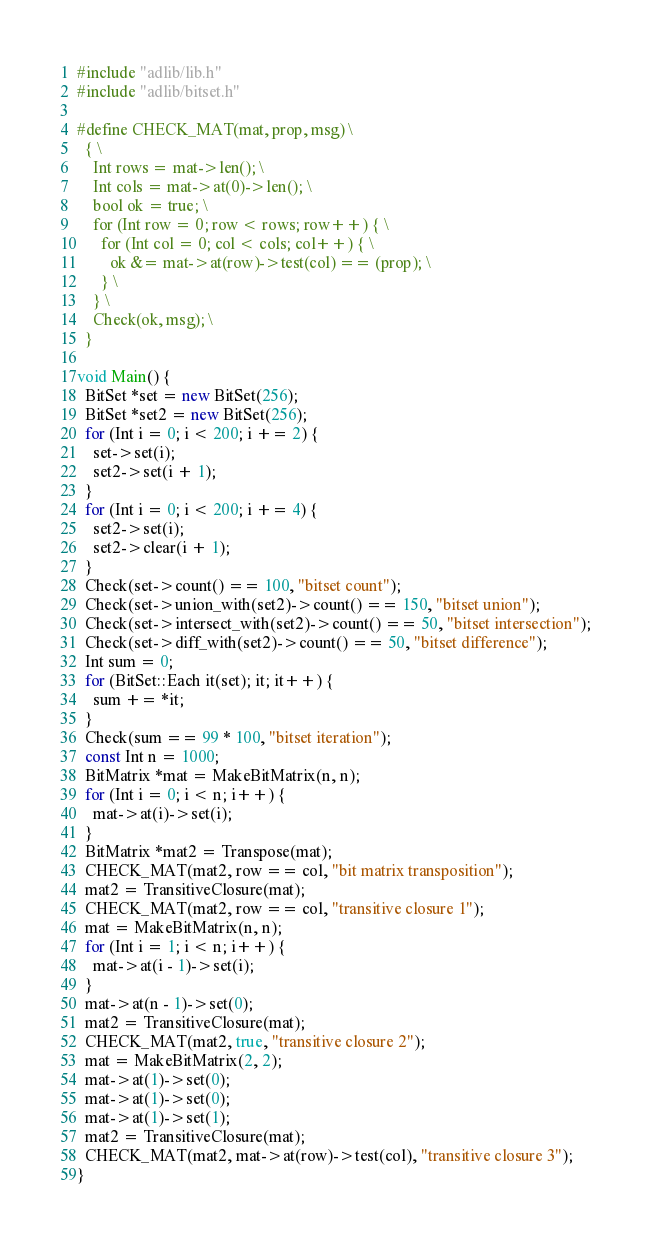<code> <loc_0><loc_0><loc_500><loc_500><_C++_>#include "adlib/lib.h"
#include "adlib/bitset.h"

#define CHECK_MAT(mat, prop, msg) \
  { \
    Int rows = mat->len(); \
    Int cols = mat->at(0)->len(); \
    bool ok = true; \
    for (Int row = 0; row < rows; row++) { \
      for (Int col = 0; col < cols; col++) { \
        ok &= mat->at(row)->test(col) == (prop); \
      } \
    } \
    Check(ok, msg); \
  }

void Main() {
  BitSet *set = new BitSet(256);
  BitSet *set2 = new BitSet(256);
  for (Int i = 0; i < 200; i += 2) {
    set->set(i);
    set2->set(i + 1);
  }
  for (Int i = 0; i < 200; i += 4) {
    set2->set(i);
    set2->clear(i + 1);
  }
  Check(set->count() == 100, "bitset count");
  Check(set->union_with(set2)->count() == 150, "bitset union");
  Check(set->intersect_with(set2)->count() == 50, "bitset intersection");
  Check(set->diff_with(set2)->count() == 50, "bitset difference");
  Int sum = 0;
  for (BitSet::Each it(set); it; it++) {
    sum += *it;
  }
  Check(sum == 99 * 100, "bitset iteration");
  const Int n = 1000;
  BitMatrix *mat = MakeBitMatrix(n, n);
  for (Int i = 0; i < n; i++) {
    mat->at(i)->set(i);
  }
  BitMatrix *mat2 = Transpose(mat);
  CHECK_MAT(mat2, row == col, "bit matrix transposition");
  mat2 = TransitiveClosure(mat);
  CHECK_MAT(mat2, row == col, "transitive closure 1");
  mat = MakeBitMatrix(n, n);
  for (Int i = 1; i < n; i++) {
    mat->at(i - 1)->set(i);
  }
  mat->at(n - 1)->set(0);
  mat2 = TransitiveClosure(mat);
  CHECK_MAT(mat2, true, "transitive closure 2");
  mat = MakeBitMatrix(2, 2);
  mat->at(1)->set(0);
  mat->at(1)->set(0);
  mat->at(1)->set(1);
  mat2 = TransitiveClosure(mat);
  CHECK_MAT(mat2, mat->at(row)->test(col), "transitive closure 3");
}
</code> 